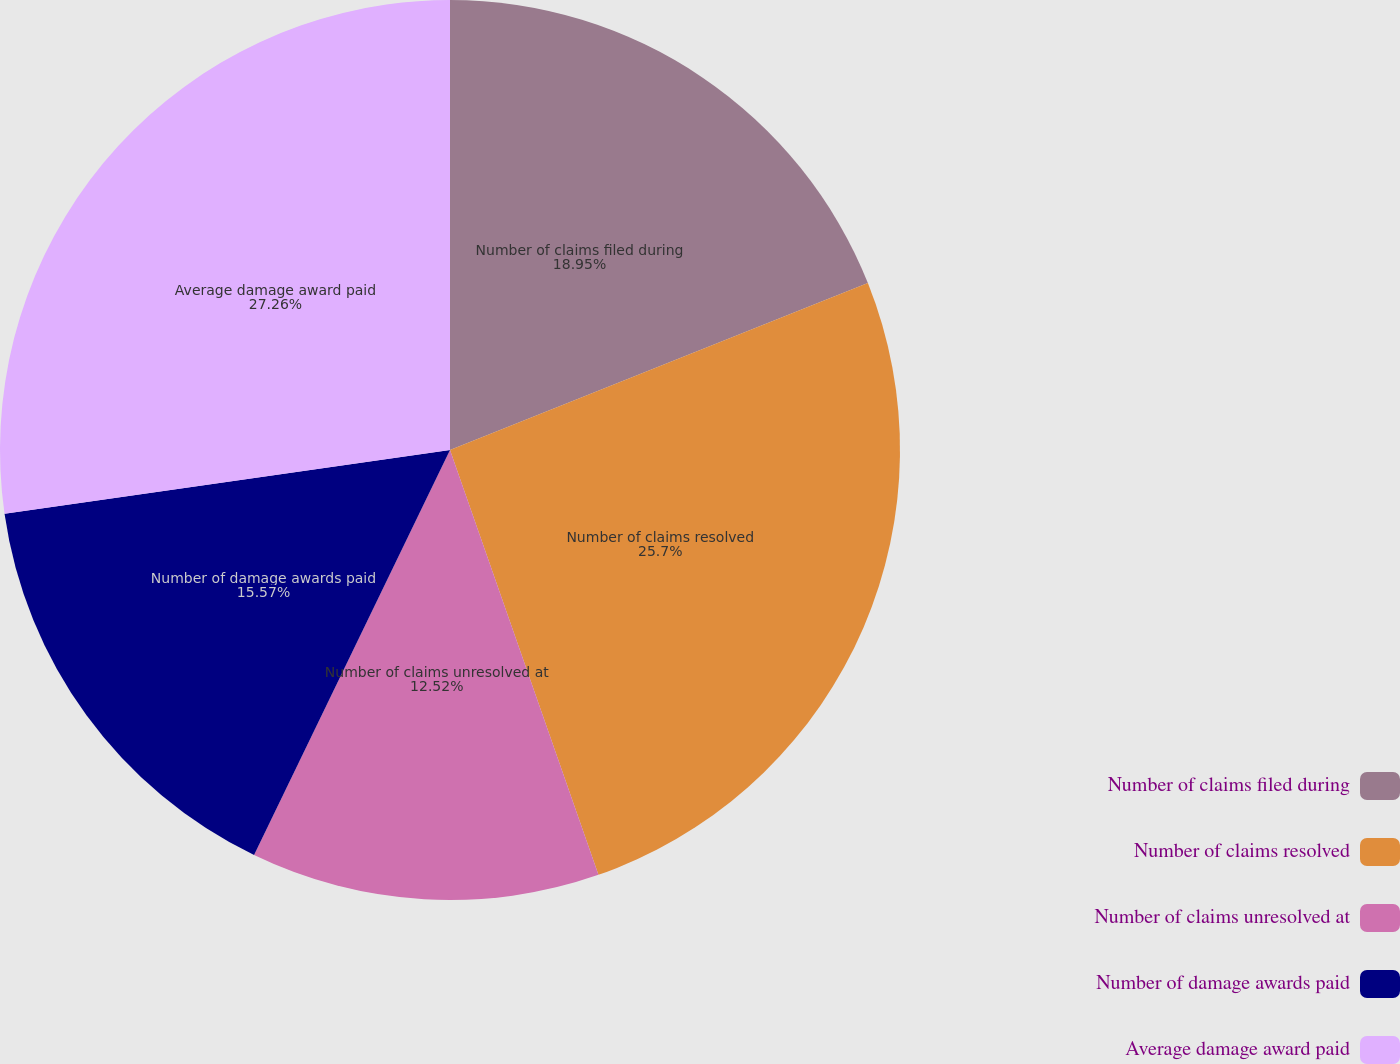Convert chart to OTSL. <chart><loc_0><loc_0><loc_500><loc_500><pie_chart><fcel>Number of claims filed during<fcel>Number of claims resolved<fcel>Number of claims unresolved at<fcel>Number of damage awards paid<fcel>Average damage award paid<nl><fcel>18.95%<fcel>25.7%<fcel>12.52%<fcel>15.57%<fcel>27.26%<nl></chart> 